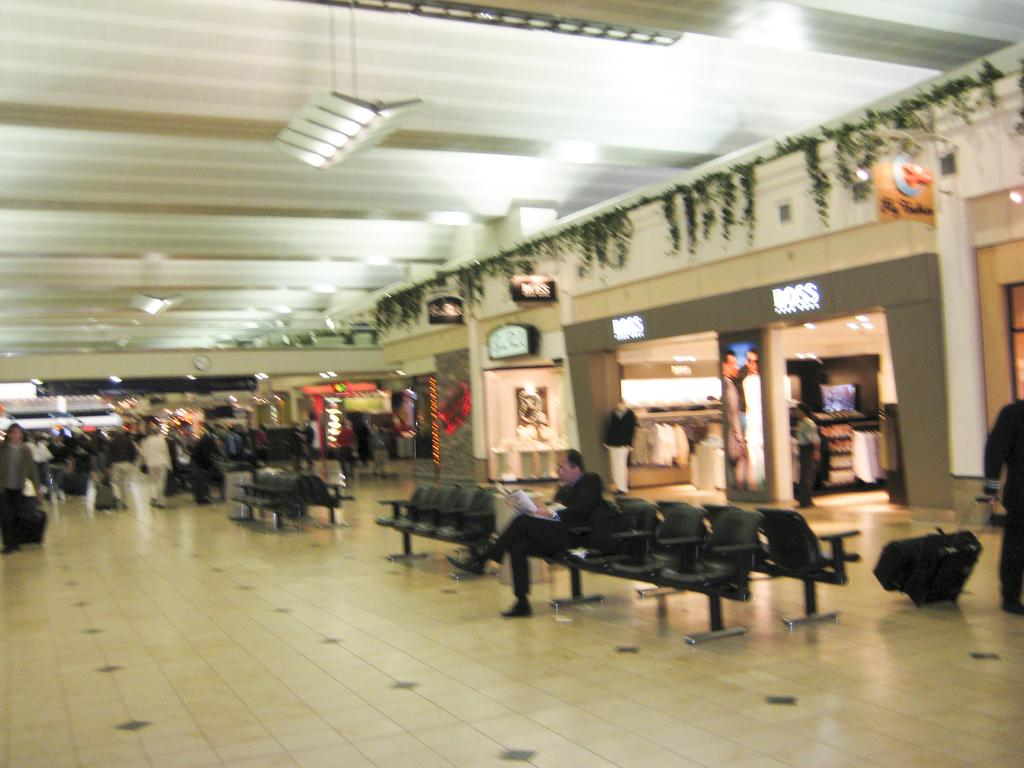What type of furniture can be seen in the image? There are chairs in the image. Can you describe the people in the image? There are people in the image. What type of establishments are present in the image? There are stores in the image. What can be seen illuminating the area in the image? There are lights in the image. What type of signage is present in the image? There are boards in the image. What is one person doing in the image? One person is sitting and holding something. How many rabbits can be seen hopping around in the image? There are no rabbits present in the image. What type of dock can be seen in the image? There is no dock present in the image. 